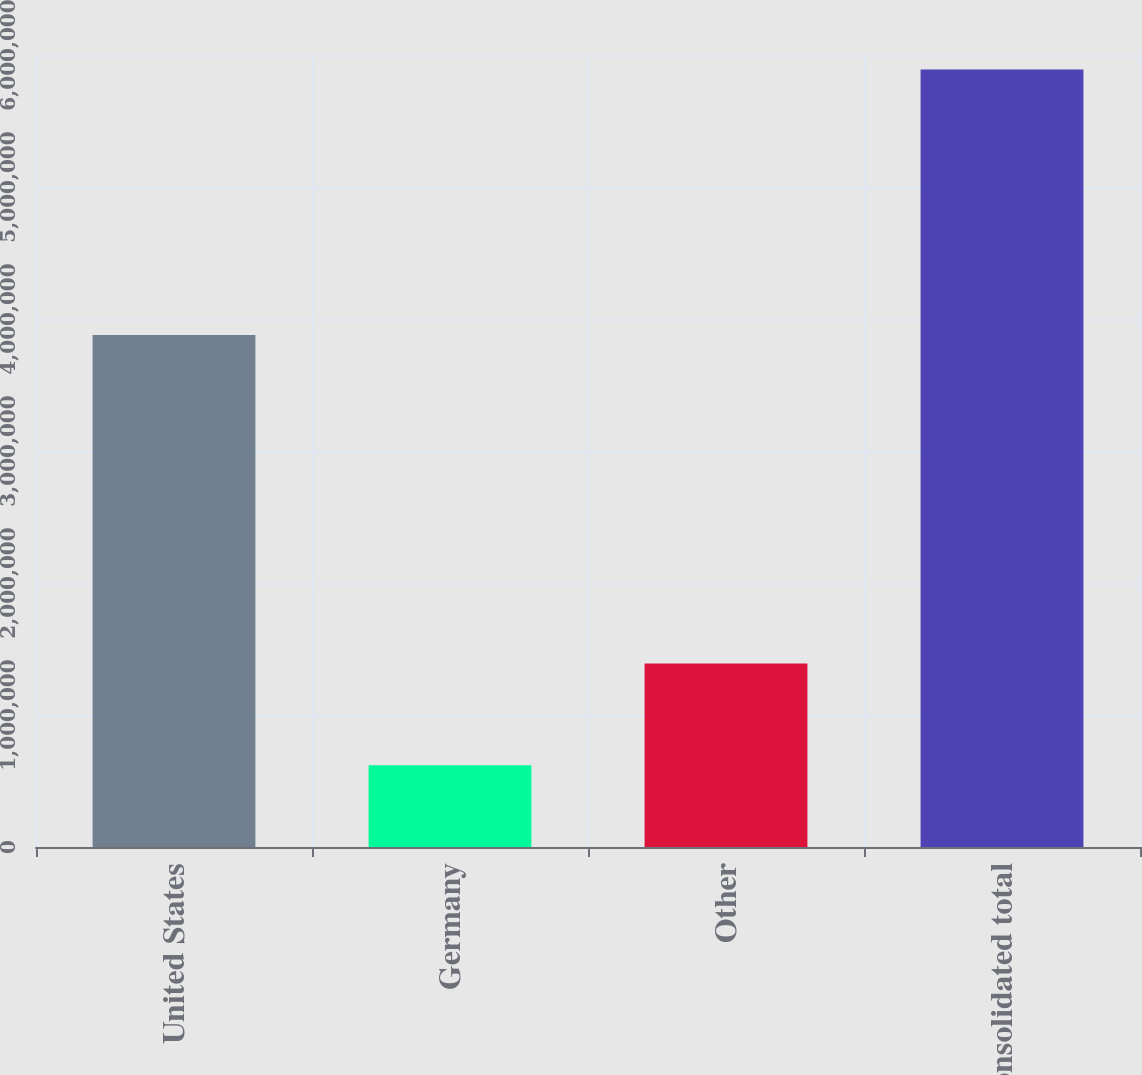Convert chart to OTSL. <chart><loc_0><loc_0><loc_500><loc_500><bar_chart><fcel>United States<fcel>Germany<fcel>Other<fcel>Consolidated total<nl><fcel>3.87858e+06<fcel>620210<fcel>1.39109e+06<fcel>5.88988e+06<nl></chart> 